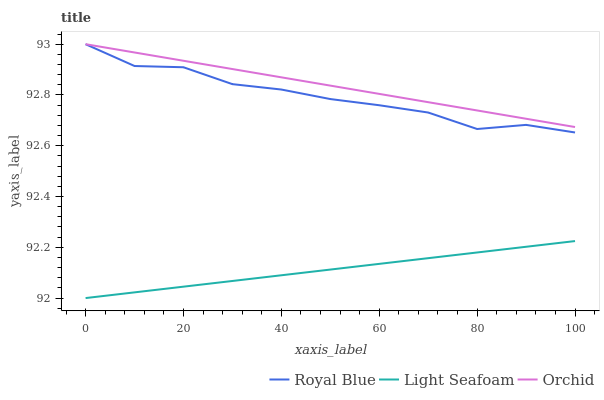Does Light Seafoam have the minimum area under the curve?
Answer yes or no. Yes. Does Orchid have the maximum area under the curve?
Answer yes or no. Yes. Does Orchid have the minimum area under the curve?
Answer yes or no. No. Does Light Seafoam have the maximum area under the curve?
Answer yes or no. No. Is Light Seafoam the smoothest?
Answer yes or no. Yes. Is Royal Blue the roughest?
Answer yes or no. Yes. Is Orchid the roughest?
Answer yes or no. No. Does Light Seafoam have the lowest value?
Answer yes or no. Yes. Does Orchid have the lowest value?
Answer yes or no. No. Does Orchid have the highest value?
Answer yes or no. Yes. Does Light Seafoam have the highest value?
Answer yes or no. No. Is Light Seafoam less than Royal Blue?
Answer yes or no. Yes. Is Orchid greater than Light Seafoam?
Answer yes or no. Yes. Does Royal Blue intersect Orchid?
Answer yes or no. Yes. Is Royal Blue less than Orchid?
Answer yes or no. No. Is Royal Blue greater than Orchid?
Answer yes or no. No. Does Light Seafoam intersect Royal Blue?
Answer yes or no. No. 